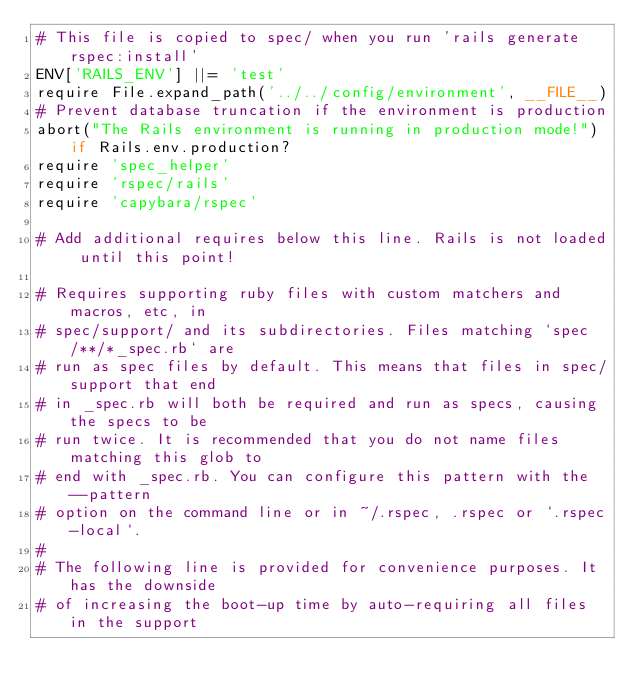<code> <loc_0><loc_0><loc_500><loc_500><_Ruby_># This file is copied to spec/ when you run 'rails generate rspec:install'
ENV['RAILS_ENV'] ||= 'test'
require File.expand_path('../../config/environment', __FILE__)
# Prevent database truncation if the environment is production
abort("The Rails environment is running in production mode!") if Rails.env.production?
require 'spec_helper'
require 'rspec/rails'
require 'capybara/rspec'

# Add additional requires below this line. Rails is not loaded until this point!

# Requires supporting ruby files with custom matchers and macros, etc, in
# spec/support/ and its subdirectories. Files matching `spec/**/*_spec.rb` are
# run as spec files by default. This means that files in spec/support that end
# in _spec.rb will both be required and run as specs, causing the specs to be
# run twice. It is recommended that you do not name files matching this glob to
# end with _spec.rb. You can configure this pattern with the --pattern
# option on the command line or in ~/.rspec, .rspec or `.rspec-local`.
#
# The following line is provided for convenience purposes. It has the downside
# of increasing the boot-up time by auto-requiring all files in the support</code> 